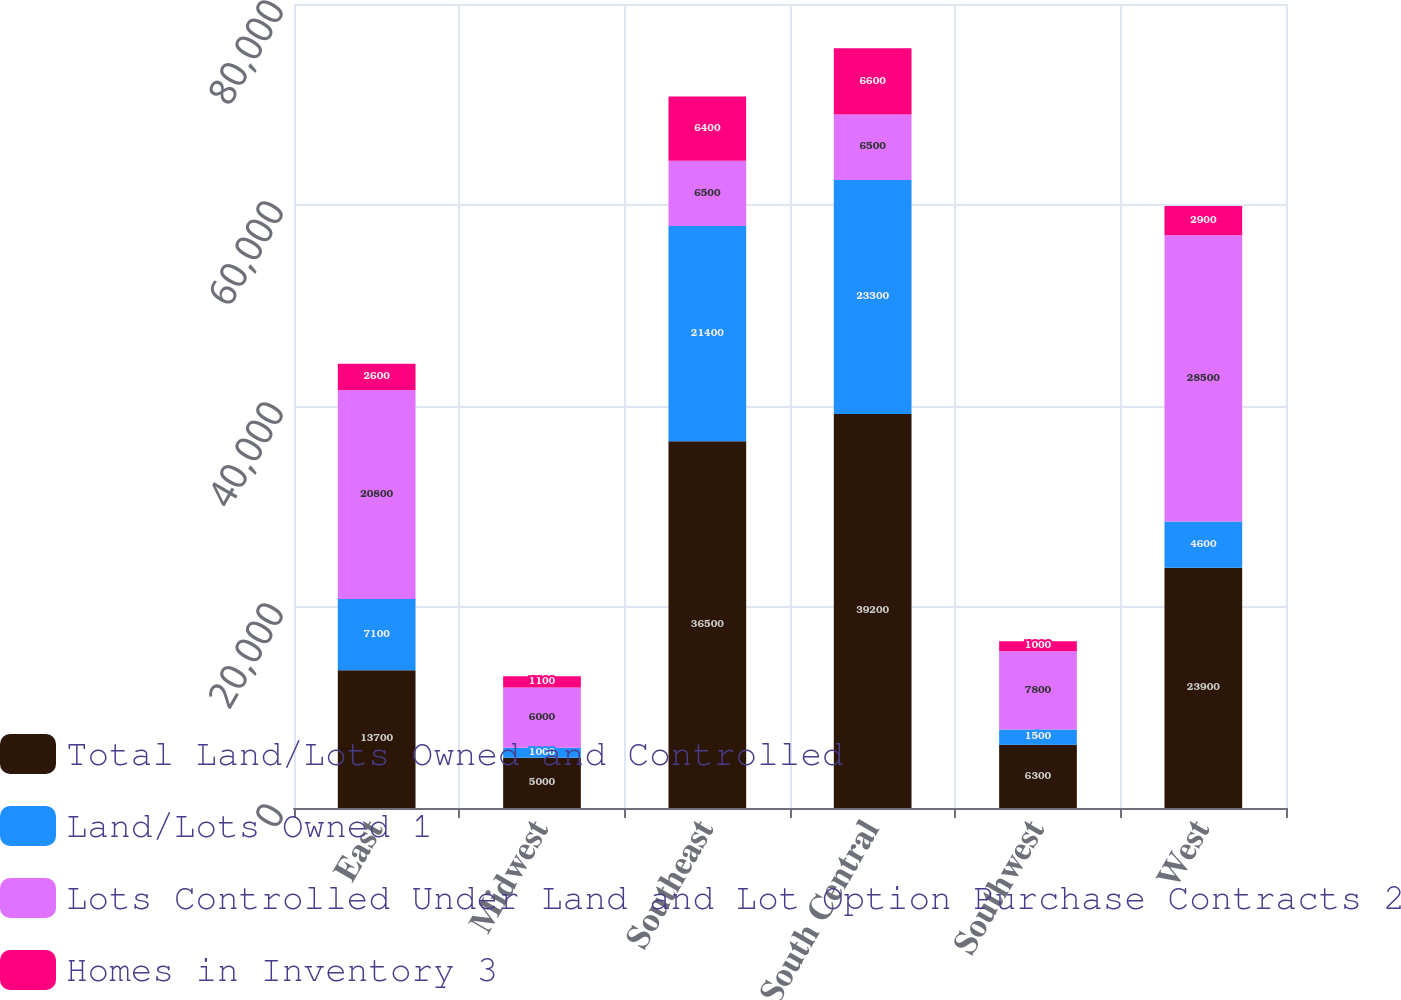<chart> <loc_0><loc_0><loc_500><loc_500><stacked_bar_chart><ecel><fcel>East<fcel>Midwest<fcel>Southeast<fcel>South Central<fcel>Southwest<fcel>West<nl><fcel>Total Land/Lots Owned and Controlled<fcel>13700<fcel>5000<fcel>36500<fcel>39200<fcel>6300<fcel>23900<nl><fcel>Land/Lots Owned 1<fcel>7100<fcel>1000<fcel>21400<fcel>23300<fcel>1500<fcel>4600<nl><fcel>Lots Controlled Under Land and Lot Option Purchase Contracts 2<fcel>20800<fcel>6000<fcel>6500<fcel>6500<fcel>7800<fcel>28500<nl><fcel>Homes in Inventory 3<fcel>2600<fcel>1100<fcel>6400<fcel>6600<fcel>1000<fcel>2900<nl></chart> 